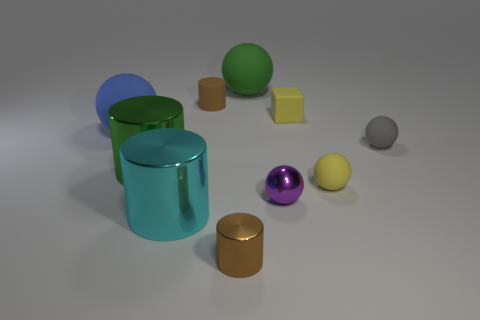Does the cyan thing have the same size as the yellow rubber sphere?
Ensure brevity in your answer.  No. What number of blocks are tiny blue rubber things or brown rubber objects?
Provide a succinct answer. 0. What number of objects are behind the yellow rubber cube and on the right side of the tiny purple metal ball?
Your answer should be very brief. 0. Does the blue sphere have the same size as the rubber ball behind the big blue matte thing?
Provide a succinct answer. Yes. There is a big sphere that is to the left of the large green thing that is behind the blue rubber object; are there any tiny brown cylinders in front of it?
Your response must be concise. Yes. What is the material of the tiny ball in front of the matte object that is in front of the large green cylinder?
Your answer should be very brief. Metal. What material is the tiny thing that is on the left side of the purple thing and in front of the gray rubber ball?
Ensure brevity in your answer.  Metal. Are there any other large things of the same shape as the purple object?
Your response must be concise. Yes. There is a green object to the right of the cyan thing; are there any shiny cylinders on the left side of it?
Offer a terse response. Yes. What number of large objects have the same material as the green ball?
Offer a terse response. 1. 